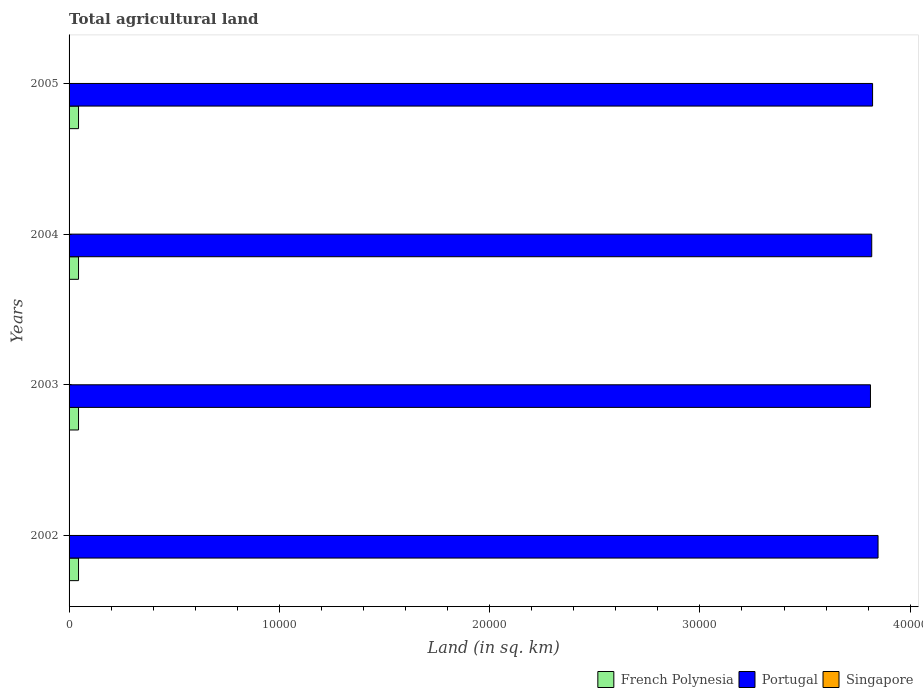How many different coloured bars are there?
Provide a short and direct response. 3. How many groups of bars are there?
Your response must be concise. 4. Are the number of bars per tick equal to the number of legend labels?
Ensure brevity in your answer.  Yes. How many bars are there on the 3rd tick from the bottom?
Your response must be concise. 3. What is the label of the 3rd group of bars from the top?
Offer a terse response. 2003. What is the total agricultural land in French Polynesia in 2002?
Your answer should be compact. 450. In which year was the total agricultural land in French Polynesia maximum?
Offer a terse response. 2002. In which year was the total agricultural land in French Polynesia minimum?
Offer a very short reply. 2002. What is the total total agricultural land in Portugal in the graph?
Your answer should be compact. 1.53e+05. What is the difference between the total agricultural land in Singapore in 2002 and that in 2005?
Provide a short and direct response. 4.4. What is the difference between the total agricultural land in French Polynesia in 2004 and the total agricultural land in Singapore in 2005?
Make the answer very short. 442.4. What is the average total agricultural land in French Polynesia per year?
Offer a very short reply. 450. In the year 2005, what is the difference between the total agricultural land in Portugal and total agricultural land in Singapore?
Make the answer very short. 3.82e+04. In how many years, is the total agricultural land in Portugal greater than 38000 sq.km?
Make the answer very short. 4. Is the total agricultural land in Singapore in 2002 less than that in 2005?
Keep it short and to the point. No. What is the difference between the highest and the second highest total agricultural land in Portugal?
Your answer should be compact. 260. What is the difference between the highest and the lowest total agricultural land in Portugal?
Offer a very short reply. 360. In how many years, is the total agricultural land in French Polynesia greater than the average total agricultural land in French Polynesia taken over all years?
Your response must be concise. 0. What does the 1st bar from the top in 2002 represents?
Give a very brief answer. Singapore. What does the 2nd bar from the bottom in 2005 represents?
Your response must be concise. Portugal. How many bars are there?
Your answer should be compact. 12. How many years are there in the graph?
Provide a short and direct response. 4. Does the graph contain grids?
Your answer should be very brief. No. How many legend labels are there?
Provide a short and direct response. 3. How are the legend labels stacked?
Your answer should be compact. Horizontal. What is the title of the graph?
Ensure brevity in your answer.  Total agricultural land. What is the label or title of the X-axis?
Ensure brevity in your answer.  Land (in sq. km). What is the Land (in sq. km) in French Polynesia in 2002?
Provide a short and direct response. 450. What is the Land (in sq. km) in Portugal in 2002?
Offer a very short reply. 3.85e+04. What is the Land (in sq. km) in French Polynesia in 2003?
Offer a terse response. 450. What is the Land (in sq. km) of Portugal in 2003?
Keep it short and to the point. 3.81e+04. What is the Land (in sq. km) of Singapore in 2003?
Your response must be concise. 8. What is the Land (in sq. km) in French Polynesia in 2004?
Your response must be concise. 450. What is the Land (in sq. km) in Portugal in 2004?
Ensure brevity in your answer.  3.82e+04. What is the Land (in sq. km) in Singapore in 2004?
Offer a very short reply. 8. What is the Land (in sq. km) in French Polynesia in 2005?
Your response must be concise. 450. What is the Land (in sq. km) of Portugal in 2005?
Provide a short and direct response. 3.82e+04. Across all years, what is the maximum Land (in sq. km) of French Polynesia?
Your answer should be very brief. 450. Across all years, what is the maximum Land (in sq. km) of Portugal?
Offer a terse response. 3.85e+04. Across all years, what is the minimum Land (in sq. km) in French Polynesia?
Offer a terse response. 450. Across all years, what is the minimum Land (in sq. km) in Portugal?
Your answer should be compact. 3.81e+04. What is the total Land (in sq. km) of French Polynesia in the graph?
Keep it short and to the point. 1800. What is the total Land (in sq. km) of Portugal in the graph?
Offer a very short reply. 1.53e+05. What is the total Land (in sq. km) of Singapore in the graph?
Your answer should be compact. 35.6. What is the difference between the Land (in sq. km) of French Polynesia in 2002 and that in 2003?
Offer a very short reply. 0. What is the difference between the Land (in sq. km) in Portugal in 2002 and that in 2003?
Your answer should be compact. 360. What is the difference between the Land (in sq. km) of Portugal in 2002 and that in 2004?
Keep it short and to the point. 300. What is the difference between the Land (in sq. km) of French Polynesia in 2002 and that in 2005?
Your answer should be very brief. 0. What is the difference between the Land (in sq. km) of Portugal in 2002 and that in 2005?
Your answer should be compact. 260. What is the difference between the Land (in sq. km) in French Polynesia in 2003 and that in 2004?
Provide a short and direct response. 0. What is the difference between the Land (in sq. km) in Portugal in 2003 and that in 2004?
Provide a succinct answer. -60. What is the difference between the Land (in sq. km) of Portugal in 2003 and that in 2005?
Give a very brief answer. -100. What is the difference between the Land (in sq. km) in French Polynesia in 2004 and that in 2005?
Make the answer very short. 0. What is the difference between the Land (in sq. km) in Portugal in 2004 and that in 2005?
Give a very brief answer. -40. What is the difference between the Land (in sq. km) in Singapore in 2004 and that in 2005?
Provide a succinct answer. 0.4. What is the difference between the Land (in sq. km) of French Polynesia in 2002 and the Land (in sq. km) of Portugal in 2003?
Make the answer very short. -3.77e+04. What is the difference between the Land (in sq. km) of French Polynesia in 2002 and the Land (in sq. km) of Singapore in 2003?
Offer a terse response. 442. What is the difference between the Land (in sq. km) in Portugal in 2002 and the Land (in sq. km) in Singapore in 2003?
Your answer should be compact. 3.85e+04. What is the difference between the Land (in sq. km) of French Polynesia in 2002 and the Land (in sq. km) of Portugal in 2004?
Your answer should be very brief. -3.77e+04. What is the difference between the Land (in sq. km) in French Polynesia in 2002 and the Land (in sq. km) in Singapore in 2004?
Keep it short and to the point. 442. What is the difference between the Land (in sq. km) of Portugal in 2002 and the Land (in sq. km) of Singapore in 2004?
Provide a succinct answer. 3.85e+04. What is the difference between the Land (in sq. km) in French Polynesia in 2002 and the Land (in sq. km) in Portugal in 2005?
Ensure brevity in your answer.  -3.78e+04. What is the difference between the Land (in sq. km) in French Polynesia in 2002 and the Land (in sq. km) in Singapore in 2005?
Keep it short and to the point. 442.4. What is the difference between the Land (in sq. km) of Portugal in 2002 and the Land (in sq. km) of Singapore in 2005?
Your response must be concise. 3.85e+04. What is the difference between the Land (in sq. km) of French Polynesia in 2003 and the Land (in sq. km) of Portugal in 2004?
Ensure brevity in your answer.  -3.77e+04. What is the difference between the Land (in sq. km) in French Polynesia in 2003 and the Land (in sq. km) in Singapore in 2004?
Your answer should be compact. 442. What is the difference between the Land (in sq. km) in Portugal in 2003 and the Land (in sq. km) in Singapore in 2004?
Keep it short and to the point. 3.81e+04. What is the difference between the Land (in sq. km) in French Polynesia in 2003 and the Land (in sq. km) in Portugal in 2005?
Offer a terse response. -3.78e+04. What is the difference between the Land (in sq. km) of French Polynesia in 2003 and the Land (in sq. km) of Singapore in 2005?
Make the answer very short. 442.4. What is the difference between the Land (in sq. km) of Portugal in 2003 and the Land (in sq. km) of Singapore in 2005?
Provide a succinct answer. 3.81e+04. What is the difference between the Land (in sq. km) of French Polynesia in 2004 and the Land (in sq. km) of Portugal in 2005?
Your response must be concise. -3.78e+04. What is the difference between the Land (in sq. km) in French Polynesia in 2004 and the Land (in sq. km) in Singapore in 2005?
Offer a very short reply. 442.4. What is the difference between the Land (in sq. km) of Portugal in 2004 and the Land (in sq. km) of Singapore in 2005?
Give a very brief answer. 3.82e+04. What is the average Land (in sq. km) of French Polynesia per year?
Your answer should be compact. 450. What is the average Land (in sq. km) in Portugal per year?
Your answer should be compact. 3.82e+04. What is the average Land (in sq. km) of Singapore per year?
Your response must be concise. 8.9. In the year 2002, what is the difference between the Land (in sq. km) of French Polynesia and Land (in sq. km) of Portugal?
Give a very brief answer. -3.80e+04. In the year 2002, what is the difference between the Land (in sq. km) of French Polynesia and Land (in sq. km) of Singapore?
Keep it short and to the point. 438. In the year 2002, what is the difference between the Land (in sq. km) of Portugal and Land (in sq. km) of Singapore?
Your answer should be very brief. 3.85e+04. In the year 2003, what is the difference between the Land (in sq. km) of French Polynesia and Land (in sq. km) of Portugal?
Keep it short and to the point. -3.77e+04. In the year 2003, what is the difference between the Land (in sq. km) in French Polynesia and Land (in sq. km) in Singapore?
Keep it short and to the point. 442. In the year 2003, what is the difference between the Land (in sq. km) of Portugal and Land (in sq. km) of Singapore?
Provide a short and direct response. 3.81e+04. In the year 2004, what is the difference between the Land (in sq. km) of French Polynesia and Land (in sq. km) of Portugal?
Make the answer very short. -3.77e+04. In the year 2004, what is the difference between the Land (in sq. km) of French Polynesia and Land (in sq. km) of Singapore?
Keep it short and to the point. 442. In the year 2004, what is the difference between the Land (in sq. km) of Portugal and Land (in sq. km) of Singapore?
Your response must be concise. 3.82e+04. In the year 2005, what is the difference between the Land (in sq. km) of French Polynesia and Land (in sq. km) of Portugal?
Offer a very short reply. -3.78e+04. In the year 2005, what is the difference between the Land (in sq. km) in French Polynesia and Land (in sq. km) in Singapore?
Make the answer very short. 442.4. In the year 2005, what is the difference between the Land (in sq. km) in Portugal and Land (in sq. km) in Singapore?
Your response must be concise. 3.82e+04. What is the ratio of the Land (in sq. km) of Portugal in 2002 to that in 2003?
Your answer should be compact. 1.01. What is the ratio of the Land (in sq. km) of Portugal in 2002 to that in 2004?
Your answer should be compact. 1.01. What is the ratio of the Land (in sq. km) in Singapore in 2002 to that in 2004?
Your answer should be very brief. 1.5. What is the ratio of the Land (in sq. km) of French Polynesia in 2002 to that in 2005?
Provide a succinct answer. 1. What is the ratio of the Land (in sq. km) in Portugal in 2002 to that in 2005?
Give a very brief answer. 1.01. What is the ratio of the Land (in sq. km) in Singapore in 2002 to that in 2005?
Your response must be concise. 1.58. What is the ratio of the Land (in sq. km) of Portugal in 2003 to that in 2004?
Provide a succinct answer. 1. What is the ratio of the Land (in sq. km) of Portugal in 2003 to that in 2005?
Keep it short and to the point. 1. What is the ratio of the Land (in sq. km) in Singapore in 2003 to that in 2005?
Offer a terse response. 1.05. What is the ratio of the Land (in sq. km) in French Polynesia in 2004 to that in 2005?
Keep it short and to the point. 1. What is the ratio of the Land (in sq. km) of Singapore in 2004 to that in 2005?
Make the answer very short. 1.05. What is the difference between the highest and the second highest Land (in sq. km) of French Polynesia?
Give a very brief answer. 0. What is the difference between the highest and the second highest Land (in sq. km) of Portugal?
Your answer should be very brief. 260. What is the difference between the highest and the second highest Land (in sq. km) of Singapore?
Offer a very short reply. 4. What is the difference between the highest and the lowest Land (in sq. km) in Portugal?
Make the answer very short. 360. 